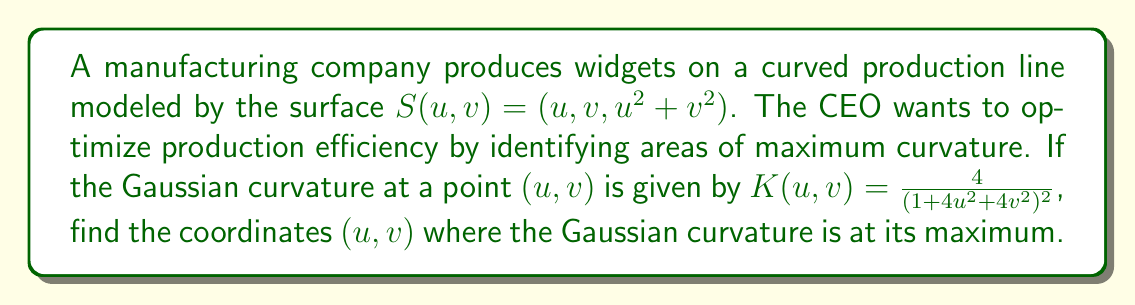Could you help me with this problem? To find the maximum Gaussian curvature, we need to follow these steps:

1) The Gaussian curvature is given by:
   $$K(u,v) = \frac{4}{(1+4u^2+4v^2)^2}$$

2) To find the maximum, we need to find the critical points by taking partial derivatives with respect to u and v and setting them to zero:

   $$\frac{\partial K}{\partial u} = \frac{-32u}{(1+4u^2+4v^2)^3} = 0$$
   $$\frac{\partial K}{\partial v} = \frac{-32v}{(1+4u^2+4v^2)^3} = 0$$

3) These equations are satisfied when $u = 0$ and $v = 0$.

4) To confirm this is a maximum, we can check the second derivatives:

   $$\frac{\partial^2 K}{\partial u^2} = \frac{-32(1+4u^2+4v^2) + 384u^2}{(1+4u^2+4v^2)^4}$$
   $$\frac{\partial^2 K}{\partial v^2} = \frac{-32(1+4u^2+4v^2) + 384v^2}{(1+4u^2+4v^2)^4}$$

   At $(0,0)$, both of these are negative, confirming a local maximum.

5) Therefore, the Gaussian curvature is at its maximum at the point $(0,0)$ on the surface.

6) The maximum value of the Gaussian curvature is:
   $$K(0,0) = \frac{4}{(1+4(0)^2+4(0)^2)^2} = 4$$
Answer: $(0,0)$ 